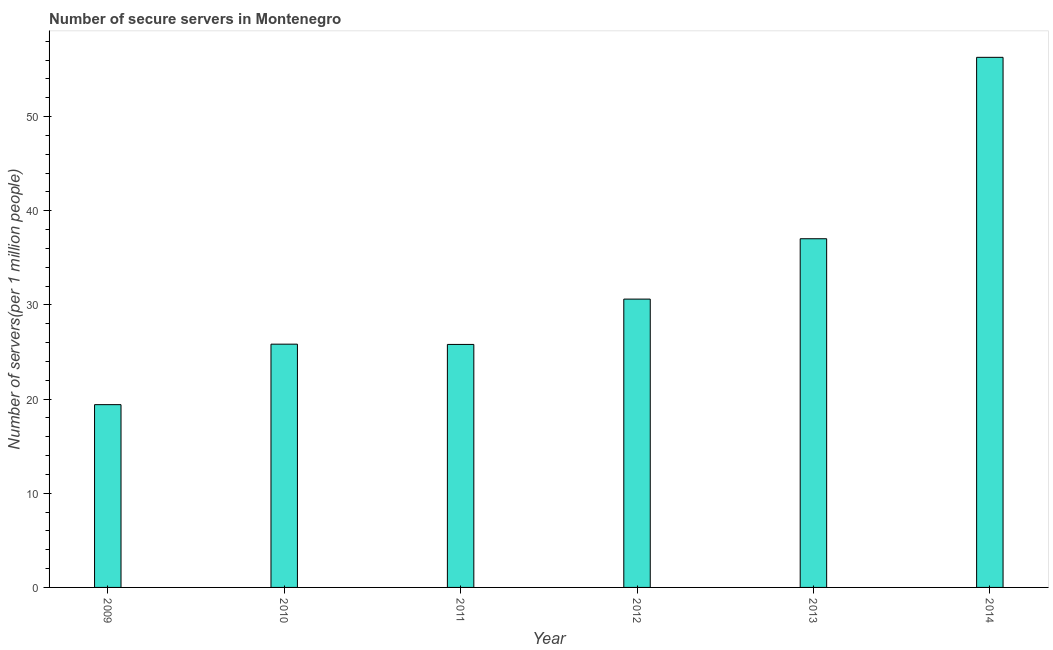Does the graph contain any zero values?
Offer a terse response. No. What is the title of the graph?
Your answer should be very brief. Number of secure servers in Montenegro. What is the label or title of the Y-axis?
Your answer should be very brief. Number of servers(per 1 million people). What is the number of secure internet servers in 2011?
Offer a terse response. 25.8. Across all years, what is the maximum number of secure internet servers?
Keep it short and to the point. 56.29. Across all years, what is the minimum number of secure internet servers?
Keep it short and to the point. 19.41. In which year was the number of secure internet servers maximum?
Your answer should be very brief. 2014. In which year was the number of secure internet servers minimum?
Make the answer very short. 2009. What is the sum of the number of secure internet servers?
Offer a terse response. 194.97. What is the difference between the number of secure internet servers in 2009 and 2013?
Keep it short and to the point. -17.62. What is the average number of secure internet servers per year?
Make the answer very short. 32.49. What is the median number of secure internet servers?
Offer a very short reply. 28.22. In how many years, is the number of secure internet servers greater than 14 ?
Your answer should be very brief. 6. What is the ratio of the number of secure internet servers in 2010 to that in 2013?
Give a very brief answer. 0.7. Is the number of secure internet servers in 2013 less than that in 2014?
Offer a terse response. Yes. Is the difference between the number of secure internet servers in 2009 and 2011 greater than the difference between any two years?
Provide a short and direct response. No. What is the difference between the highest and the second highest number of secure internet servers?
Ensure brevity in your answer.  19.26. Is the sum of the number of secure internet servers in 2011 and 2012 greater than the maximum number of secure internet servers across all years?
Keep it short and to the point. Yes. What is the difference between the highest and the lowest number of secure internet servers?
Ensure brevity in your answer.  36.88. In how many years, is the number of secure internet servers greater than the average number of secure internet servers taken over all years?
Make the answer very short. 2. Are all the bars in the graph horizontal?
Provide a succinct answer. No. Are the values on the major ticks of Y-axis written in scientific E-notation?
Make the answer very short. No. What is the Number of servers(per 1 million people) in 2009?
Keep it short and to the point. 19.41. What is the Number of servers(per 1 million people) in 2010?
Your response must be concise. 25.83. What is the Number of servers(per 1 million people) of 2011?
Give a very brief answer. 25.8. What is the Number of servers(per 1 million people) in 2012?
Make the answer very short. 30.62. What is the Number of servers(per 1 million people) of 2013?
Offer a very short reply. 37.02. What is the Number of servers(per 1 million people) of 2014?
Offer a very short reply. 56.29. What is the difference between the Number of servers(per 1 million people) in 2009 and 2010?
Your response must be concise. -6.42. What is the difference between the Number of servers(per 1 million people) in 2009 and 2011?
Your answer should be compact. -6.39. What is the difference between the Number of servers(per 1 million people) in 2009 and 2012?
Your answer should be compact. -11.21. What is the difference between the Number of servers(per 1 million people) in 2009 and 2013?
Give a very brief answer. -17.62. What is the difference between the Number of servers(per 1 million people) in 2009 and 2014?
Keep it short and to the point. -36.88. What is the difference between the Number of servers(per 1 million people) in 2010 and 2011?
Your response must be concise. 0.03. What is the difference between the Number of servers(per 1 million people) in 2010 and 2012?
Provide a short and direct response. -4.79. What is the difference between the Number of servers(per 1 million people) in 2010 and 2013?
Provide a succinct answer. -11.19. What is the difference between the Number of servers(per 1 million people) in 2010 and 2014?
Offer a very short reply. -30.46. What is the difference between the Number of servers(per 1 million people) in 2011 and 2012?
Ensure brevity in your answer.  -4.81. What is the difference between the Number of servers(per 1 million people) in 2011 and 2013?
Your answer should be compact. -11.22. What is the difference between the Number of servers(per 1 million people) in 2011 and 2014?
Your answer should be very brief. -30.49. What is the difference between the Number of servers(per 1 million people) in 2012 and 2013?
Keep it short and to the point. -6.41. What is the difference between the Number of servers(per 1 million people) in 2012 and 2014?
Provide a short and direct response. -25.67. What is the difference between the Number of servers(per 1 million people) in 2013 and 2014?
Ensure brevity in your answer.  -19.26. What is the ratio of the Number of servers(per 1 million people) in 2009 to that in 2010?
Make the answer very short. 0.75. What is the ratio of the Number of servers(per 1 million people) in 2009 to that in 2011?
Your answer should be compact. 0.75. What is the ratio of the Number of servers(per 1 million people) in 2009 to that in 2012?
Give a very brief answer. 0.63. What is the ratio of the Number of servers(per 1 million people) in 2009 to that in 2013?
Offer a terse response. 0.52. What is the ratio of the Number of servers(per 1 million people) in 2009 to that in 2014?
Your answer should be very brief. 0.34. What is the ratio of the Number of servers(per 1 million people) in 2010 to that in 2012?
Offer a very short reply. 0.84. What is the ratio of the Number of servers(per 1 million people) in 2010 to that in 2013?
Your response must be concise. 0.7. What is the ratio of the Number of servers(per 1 million people) in 2010 to that in 2014?
Offer a terse response. 0.46. What is the ratio of the Number of servers(per 1 million people) in 2011 to that in 2012?
Give a very brief answer. 0.84. What is the ratio of the Number of servers(per 1 million people) in 2011 to that in 2013?
Offer a terse response. 0.7. What is the ratio of the Number of servers(per 1 million people) in 2011 to that in 2014?
Give a very brief answer. 0.46. What is the ratio of the Number of servers(per 1 million people) in 2012 to that in 2013?
Offer a very short reply. 0.83. What is the ratio of the Number of servers(per 1 million people) in 2012 to that in 2014?
Provide a succinct answer. 0.54. What is the ratio of the Number of servers(per 1 million people) in 2013 to that in 2014?
Provide a short and direct response. 0.66. 